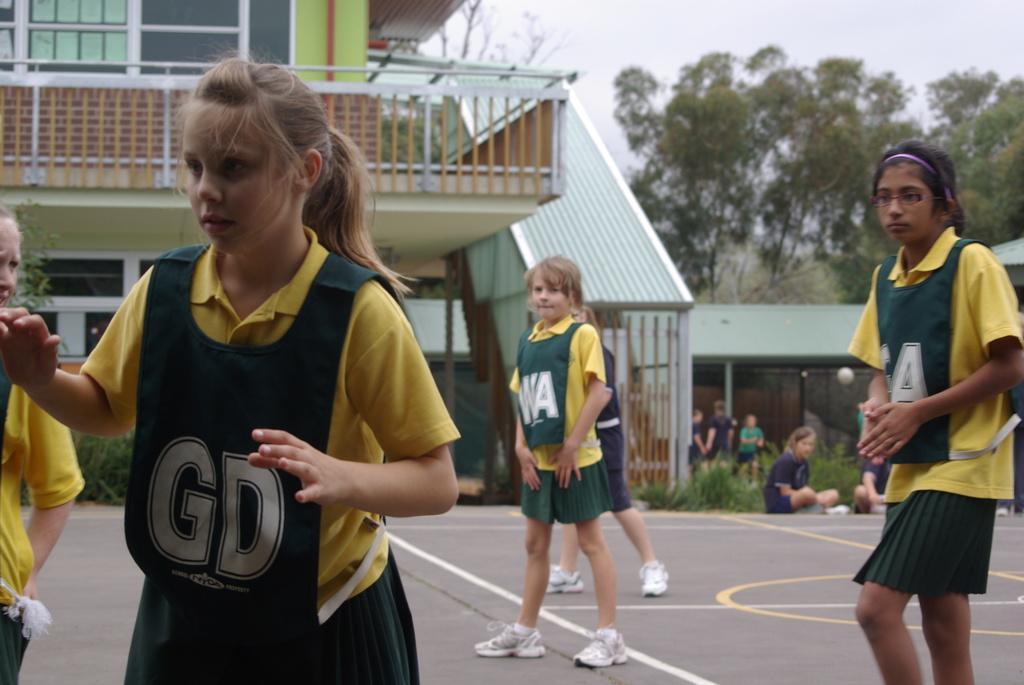Describe this image in one or two sentences. In this image we can see few people on the ground, there is a building, few plants, trees and the sky in the background. 